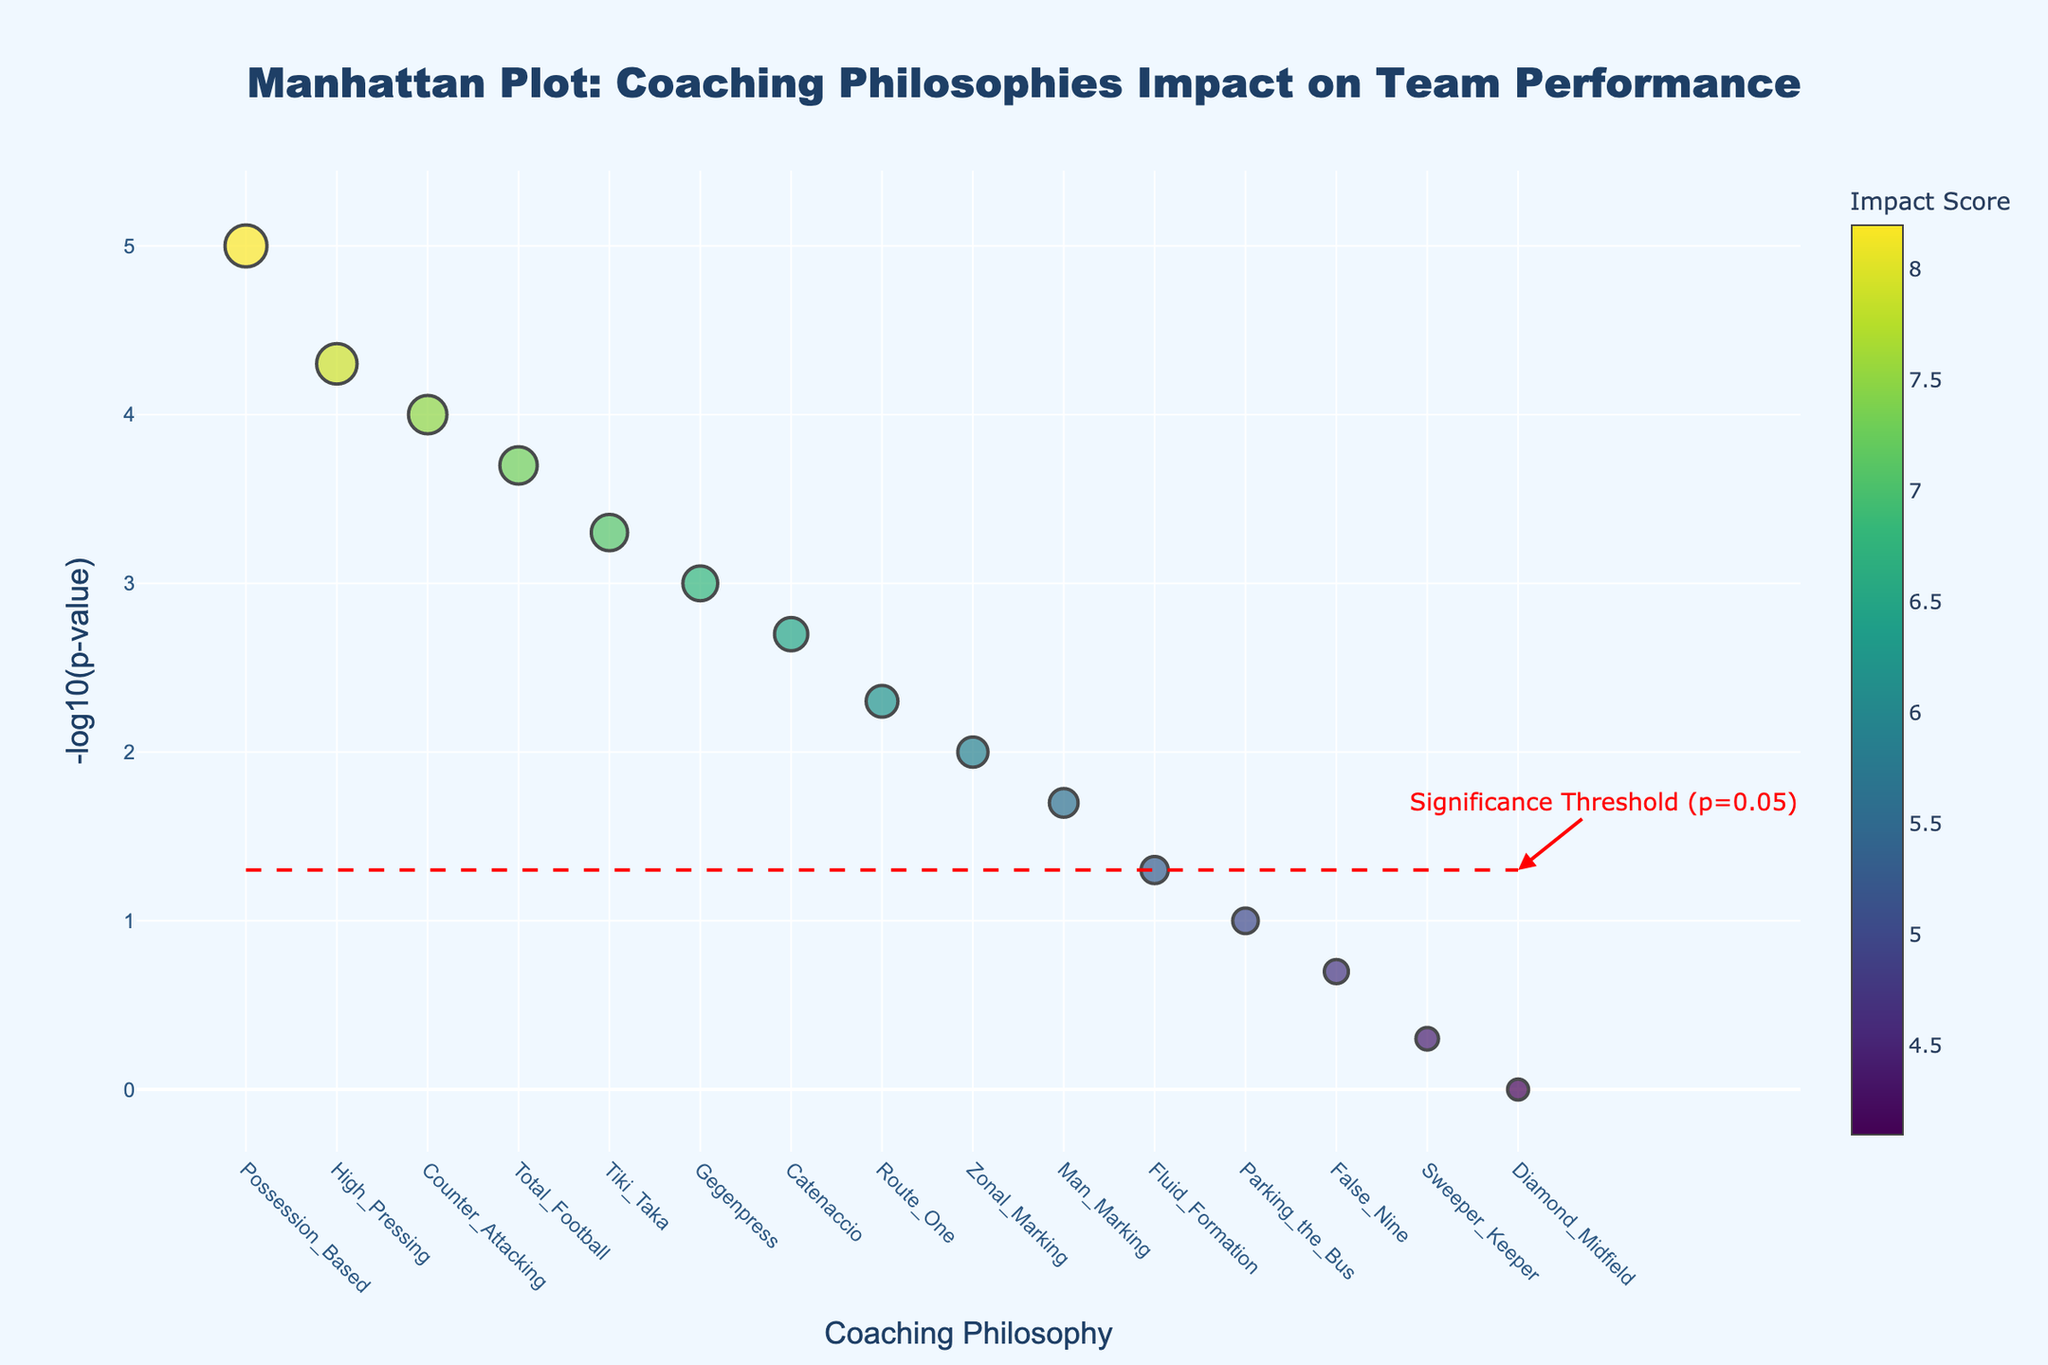What's the title of the plot? The title is positioned prominently at the top of the plot and indicates what the plot is about.
Answer: Manhattan Plot: Coaching Philosophies Impact on Team Performance How many coaching philosophies have a p-value below 0.05? The red dashed line represents the significance threshold at p=0.05, and philosophies with markers above this line have p-values below 0.05. By counting, we see these philosophies: Possession_Based, High_Pressing, Counter_Attacking, Total_Football, Tiki_Taka, Gegenpress, and Catenaccio.
Answer: 7 Which coaching philosophy has the highest impact score? The size of the markers is proportional to the impact score. The philosophy with the largest marker is Possession_Based, which has the highest impact score of 8.2.
Answer: Possession_Based What's the approximate p-value for the 'Zonal Marking' philosophy? Hovering over or examining the position of the 'Zonal Marking' marker on the y-axis provides its p-value. The y-axis uses a -log10 scale, and its value here is around 2, which means the p-value is approximately 0.01.
Answer: ~0.01 What does the red dashed line represent in the plot? The red dashed line's position correlates with a p-value of 0.05 on the -log10 scale, and the annotation near it explains it as the significance threshold.
Answer: Significance threshold (p-value=0.05) Compare the impact scores of 'High Pressing' and 'False Nine'. Which one is higher and by how much? 'High Pressing' has an impact score of 7.9 and 'False Nine' has 4.7. Subtract the smaller score from the larger one to find the difference: 7.9 - 4.7 = 3.2.
Answer: High Pressing by 3.2 Is 'Parking the Bus' philosophy statistically significant? The 'Parking the Bus' marker is below the red dashed line, indicating its p-value is higher than 0.05, thus it isn't statistically significant.
Answer: No What are the coordinates of the point representing 'Counter Attacking' philosophy? The x-coordinate is 'Counter_Attacking'. The y-coordinate is found by the position on the y-axis, which is around 4 on the -log10 scale.
Answer: (Counter_Attacking, ~4) Based on the plot, which coaching philosophy is just above the significance threshold? The philosophy situated just slightly above the red dashed line is 'Catenaccio'.
Answer: Catenaccio What is the impact score range depicted in the color scale of the markers? The color scale indicator shows that marker colors range correlating to the lowest impact score (4.1 for Diamond_Midfield) and the highest (8.2 for Possession_Based).
Answer: 4.1 to 8.2 